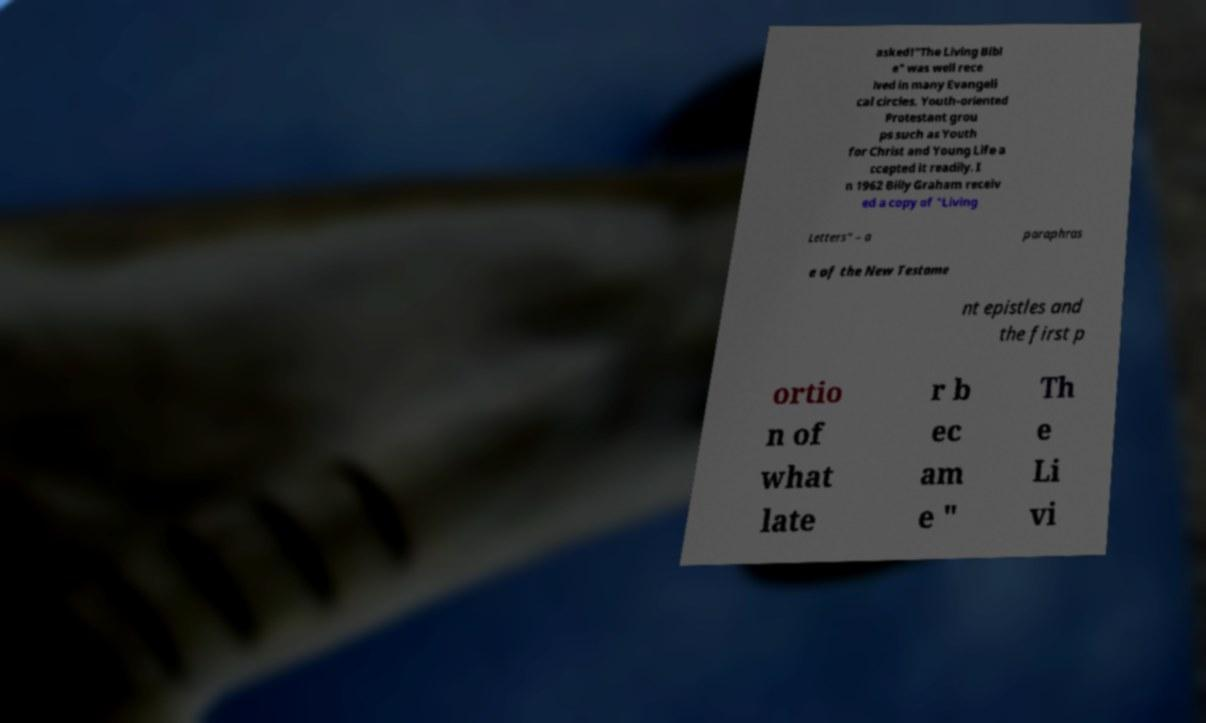There's text embedded in this image that I need extracted. Can you transcribe it verbatim? asked!"The Living Bibl e" was well rece ived in many Evangeli cal circles. Youth-oriented Protestant grou ps such as Youth for Christ and Young Life a ccepted it readily. I n 1962 Billy Graham receiv ed a copy of "Living Letters" – a paraphras e of the New Testame nt epistles and the first p ortio n of what late r b ec am e " Th e Li vi 